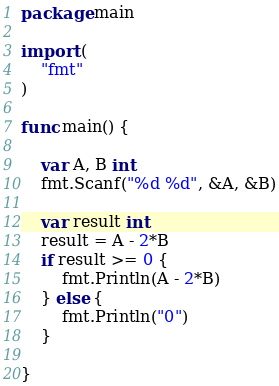Convert code to text. <code><loc_0><loc_0><loc_500><loc_500><_Go_>package main

import (
	"fmt"
)

func main() {

	var A, B int
	fmt.Scanf("%d %d", &A, &B)

	var result int
	result = A - 2*B
	if result >= 0 {
		fmt.Println(A - 2*B)
	} else {
		fmt.Println("0")
	}

}
</code> 